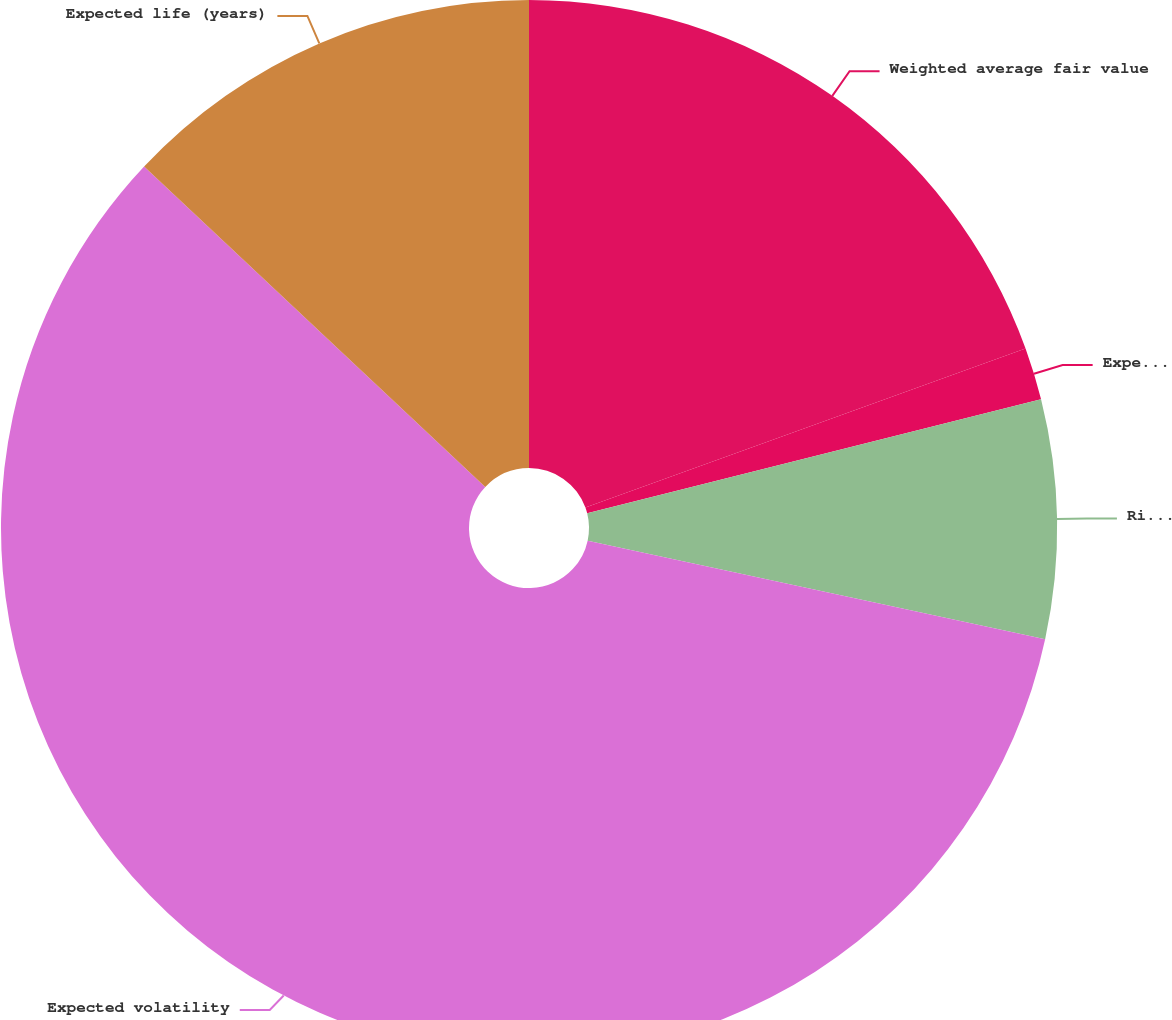<chart> <loc_0><loc_0><loc_500><loc_500><pie_chart><fcel>Weighted average fair value<fcel>Expected dividend yield<fcel>Risk-free interest rate<fcel>Expected volatility<fcel>Expected life (years)<nl><fcel>19.48%<fcel>1.6%<fcel>7.3%<fcel>58.62%<fcel>13.0%<nl></chart> 